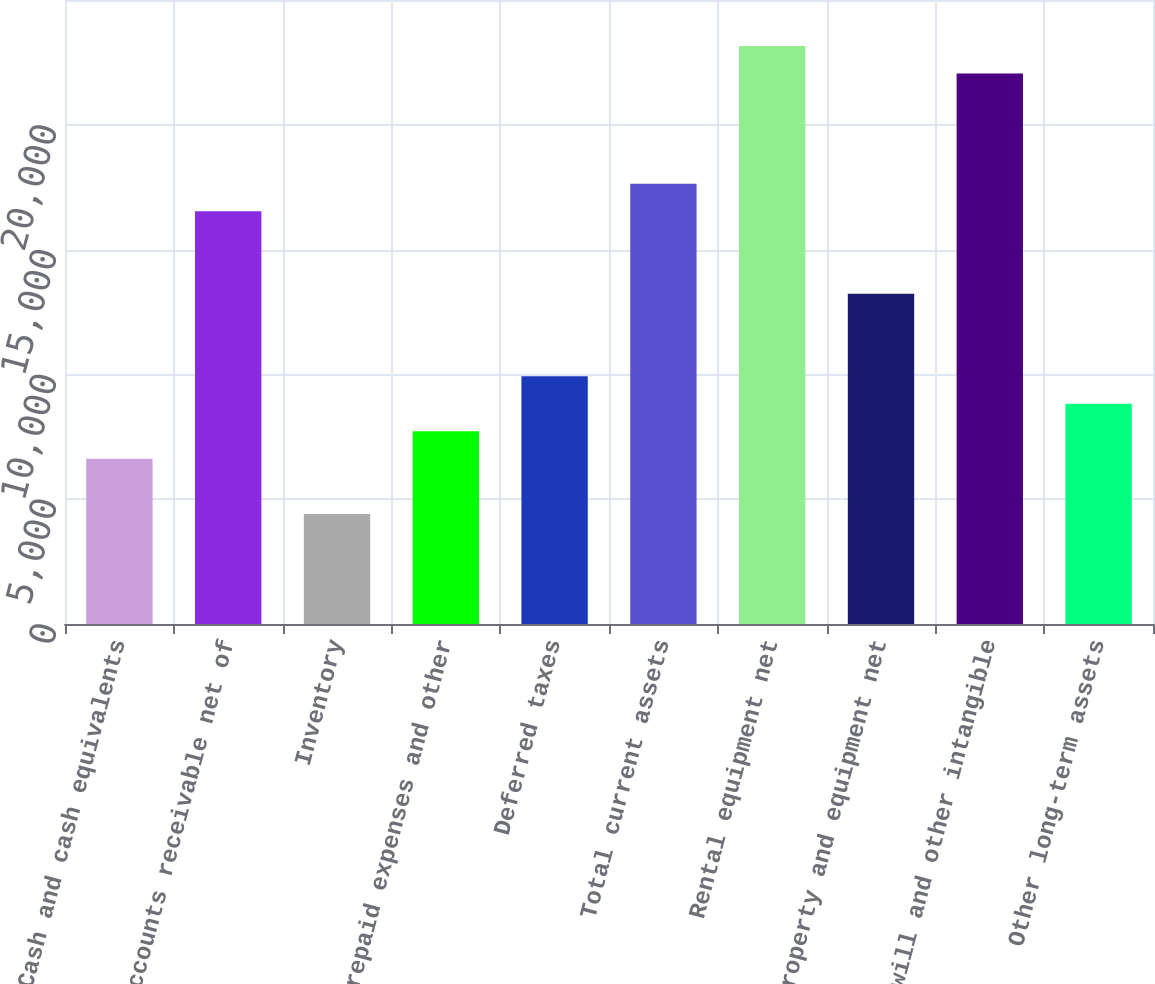Convert chart. <chart><loc_0><loc_0><loc_500><loc_500><bar_chart><fcel>Cash and cash equivalents<fcel>Accounts receivable net of<fcel>Inventory<fcel>Prepaid expenses and other<fcel>Deferred taxes<fcel>Total current assets<fcel>Rental equipment net<fcel>Property and equipment net<fcel>Goodwill and other intangible<fcel>Other long-term assets<nl><fcel>6616<fcel>16538.5<fcel>4411<fcel>7718.5<fcel>9923.5<fcel>17641<fcel>23153.5<fcel>13231<fcel>22051<fcel>8821<nl></chart> 